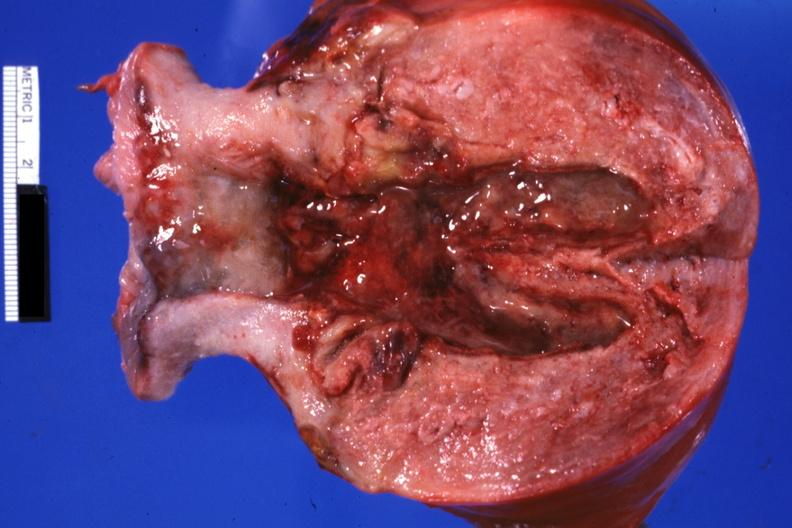what is present?
Answer the question using a single word or phrase. Female reproductive 